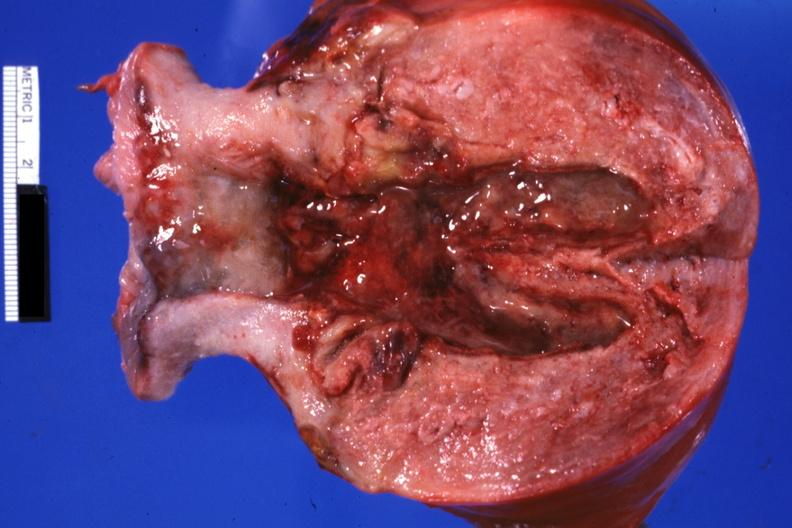what is present?
Answer the question using a single word or phrase. Female reproductive 